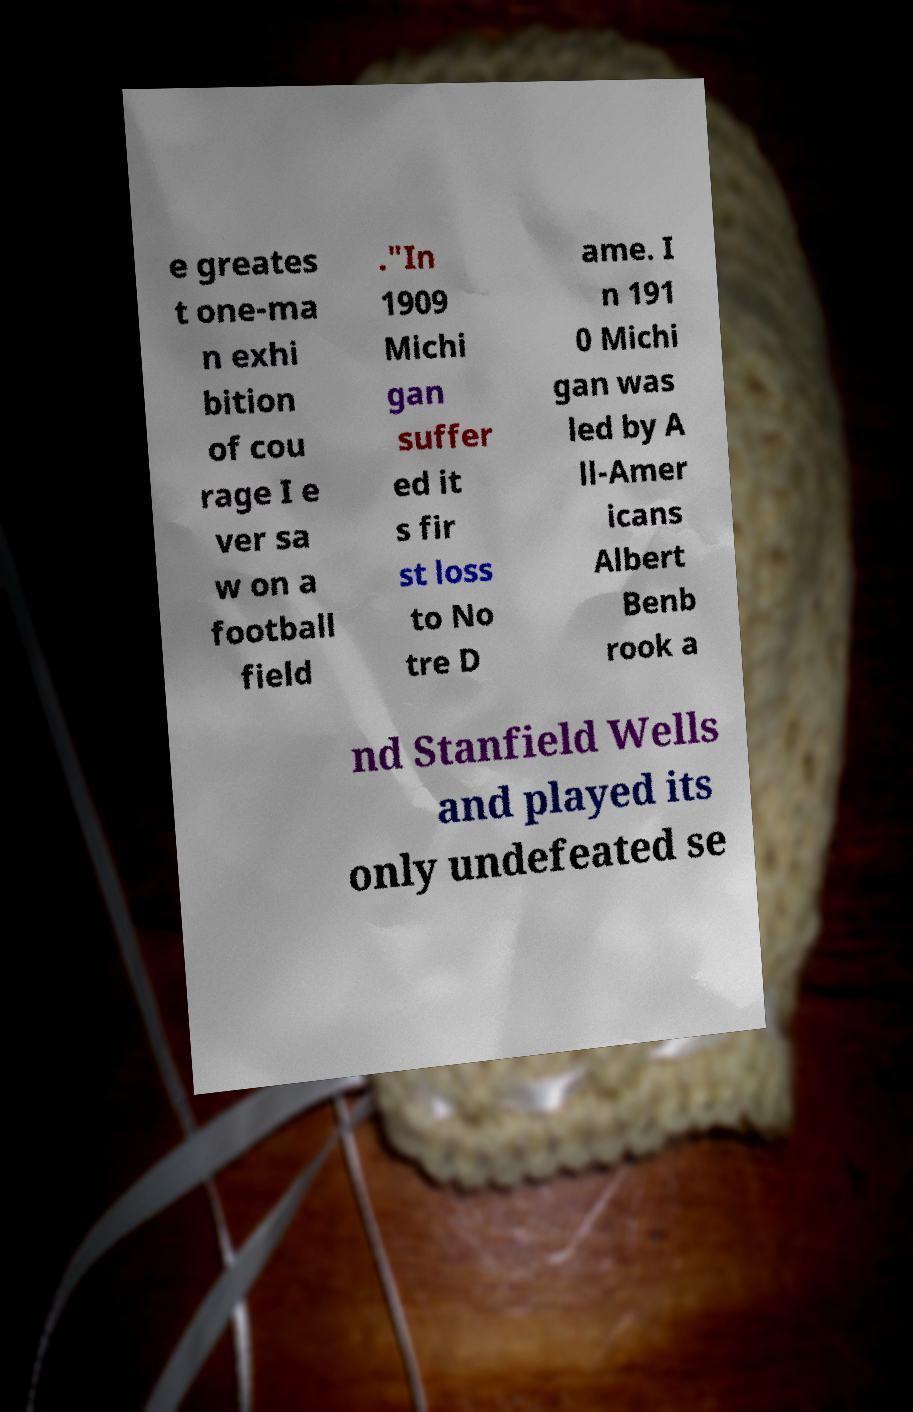There's text embedded in this image that I need extracted. Can you transcribe it verbatim? e greates t one-ma n exhi bition of cou rage I e ver sa w on a football field ."In 1909 Michi gan suffer ed it s fir st loss to No tre D ame. I n 191 0 Michi gan was led by A ll-Amer icans Albert Benb rook a nd Stanfield Wells and played its only undefeated se 